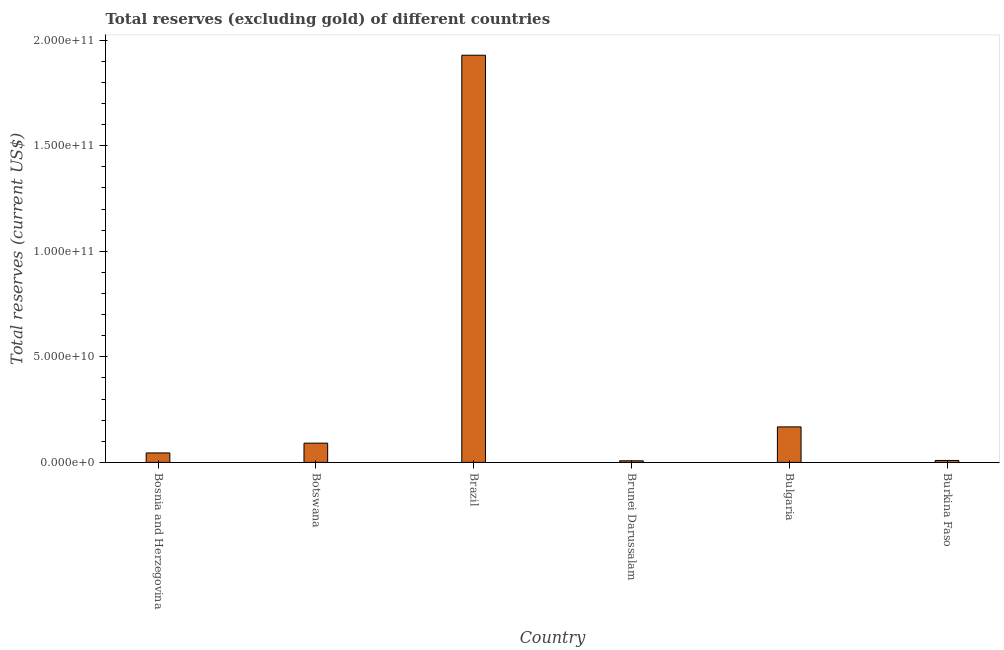What is the title of the graph?
Offer a terse response. Total reserves (excluding gold) of different countries. What is the label or title of the X-axis?
Your answer should be very brief. Country. What is the label or title of the Y-axis?
Provide a succinct answer. Total reserves (current US$). What is the total reserves (excluding gold) in Brazil?
Provide a succinct answer. 1.93e+11. Across all countries, what is the maximum total reserves (excluding gold)?
Your response must be concise. 1.93e+11. Across all countries, what is the minimum total reserves (excluding gold)?
Your response must be concise. 7.51e+08. In which country was the total reserves (excluding gold) minimum?
Provide a short and direct response. Brunei Darussalam. What is the sum of the total reserves (excluding gold)?
Offer a terse response. 2.25e+11. What is the difference between the total reserves (excluding gold) in Bosnia and Herzegovina and Brunei Darussalam?
Offer a terse response. 3.73e+09. What is the average total reserves (excluding gold) per country?
Your answer should be very brief. 3.75e+1. What is the median total reserves (excluding gold)?
Your answer should be compact. 6.80e+09. In how many countries, is the total reserves (excluding gold) greater than 20000000000 US$?
Your answer should be very brief. 1. What is the ratio of the total reserves (excluding gold) in Botswana to that in Burkina Faso?
Keep it short and to the point. 9.83. Is the total reserves (excluding gold) in Bosnia and Herzegovina less than that in Burkina Faso?
Your answer should be very brief. No. What is the difference between the highest and the second highest total reserves (excluding gold)?
Your response must be concise. 1.76e+11. Is the sum of the total reserves (excluding gold) in Brunei Darussalam and Burkina Faso greater than the maximum total reserves (excluding gold) across all countries?
Your answer should be very brief. No. What is the difference between the highest and the lowest total reserves (excluding gold)?
Your response must be concise. 1.92e+11. Are all the bars in the graph horizontal?
Offer a terse response. No. What is the difference between two consecutive major ticks on the Y-axis?
Offer a terse response. 5.00e+1. What is the Total reserves (current US$) in Bosnia and Herzegovina?
Provide a short and direct response. 4.48e+09. What is the Total reserves (current US$) in Botswana?
Provide a short and direct response. 9.12e+09. What is the Total reserves (current US$) of Brazil?
Your response must be concise. 1.93e+11. What is the Total reserves (current US$) in Brunei Darussalam?
Give a very brief answer. 7.51e+08. What is the Total reserves (current US$) of Bulgaria?
Your response must be concise. 1.68e+1. What is the Total reserves (current US$) in Burkina Faso?
Your response must be concise. 9.28e+08. What is the difference between the Total reserves (current US$) in Bosnia and Herzegovina and Botswana?
Offer a terse response. -4.64e+09. What is the difference between the Total reserves (current US$) in Bosnia and Herzegovina and Brazil?
Your response must be concise. -1.88e+11. What is the difference between the Total reserves (current US$) in Bosnia and Herzegovina and Brunei Darussalam?
Offer a terse response. 3.73e+09. What is the difference between the Total reserves (current US$) in Bosnia and Herzegovina and Bulgaria?
Provide a succinct answer. -1.23e+1. What is the difference between the Total reserves (current US$) in Bosnia and Herzegovina and Burkina Faso?
Keep it short and to the point. 3.55e+09. What is the difference between the Total reserves (current US$) in Botswana and Brazil?
Provide a succinct answer. -1.84e+11. What is the difference between the Total reserves (current US$) in Botswana and Brunei Darussalam?
Ensure brevity in your answer.  8.37e+09. What is the difference between the Total reserves (current US$) in Botswana and Bulgaria?
Your answer should be compact. -7.70e+09. What is the difference between the Total reserves (current US$) in Botswana and Burkina Faso?
Keep it short and to the point. 8.19e+09. What is the difference between the Total reserves (current US$) in Brazil and Brunei Darussalam?
Keep it short and to the point. 1.92e+11. What is the difference between the Total reserves (current US$) in Brazil and Bulgaria?
Offer a terse response. 1.76e+11. What is the difference between the Total reserves (current US$) in Brazil and Burkina Faso?
Your response must be concise. 1.92e+11. What is the difference between the Total reserves (current US$) in Brunei Darussalam and Bulgaria?
Keep it short and to the point. -1.61e+1. What is the difference between the Total reserves (current US$) in Brunei Darussalam and Burkina Faso?
Your answer should be compact. -1.76e+08. What is the difference between the Total reserves (current US$) in Bulgaria and Burkina Faso?
Ensure brevity in your answer.  1.59e+1. What is the ratio of the Total reserves (current US$) in Bosnia and Herzegovina to that in Botswana?
Ensure brevity in your answer.  0.49. What is the ratio of the Total reserves (current US$) in Bosnia and Herzegovina to that in Brazil?
Offer a terse response. 0.02. What is the ratio of the Total reserves (current US$) in Bosnia and Herzegovina to that in Brunei Darussalam?
Ensure brevity in your answer.  5.96. What is the ratio of the Total reserves (current US$) in Bosnia and Herzegovina to that in Bulgaria?
Offer a very short reply. 0.27. What is the ratio of the Total reserves (current US$) in Bosnia and Herzegovina to that in Burkina Faso?
Make the answer very short. 4.83. What is the ratio of the Total reserves (current US$) in Botswana to that in Brazil?
Make the answer very short. 0.05. What is the ratio of the Total reserves (current US$) in Botswana to that in Brunei Darussalam?
Offer a terse response. 12.14. What is the ratio of the Total reserves (current US$) in Botswana to that in Bulgaria?
Your answer should be compact. 0.54. What is the ratio of the Total reserves (current US$) in Botswana to that in Burkina Faso?
Ensure brevity in your answer.  9.83. What is the ratio of the Total reserves (current US$) in Brazil to that in Brunei Darussalam?
Offer a very short reply. 256.73. What is the ratio of the Total reserves (current US$) in Brazil to that in Bulgaria?
Your response must be concise. 11.47. What is the ratio of the Total reserves (current US$) in Brazil to that in Burkina Faso?
Your answer should be compact. 207.9. What is the ratio of the Total reserves (current US$) in Brunei Darussalam to that in Bulgaria?
Keep it short and to the point. 0.04. What is the ratio of the Total reserves (current US$) in Brunei Darussalam to that in Burkina Faso?
Give a very brief answer. 0.81. What is the ratio of the Total reserves (current US$) in Bulgaria to that in Burkina Faso?
Your answer should be compact. 18.13. 